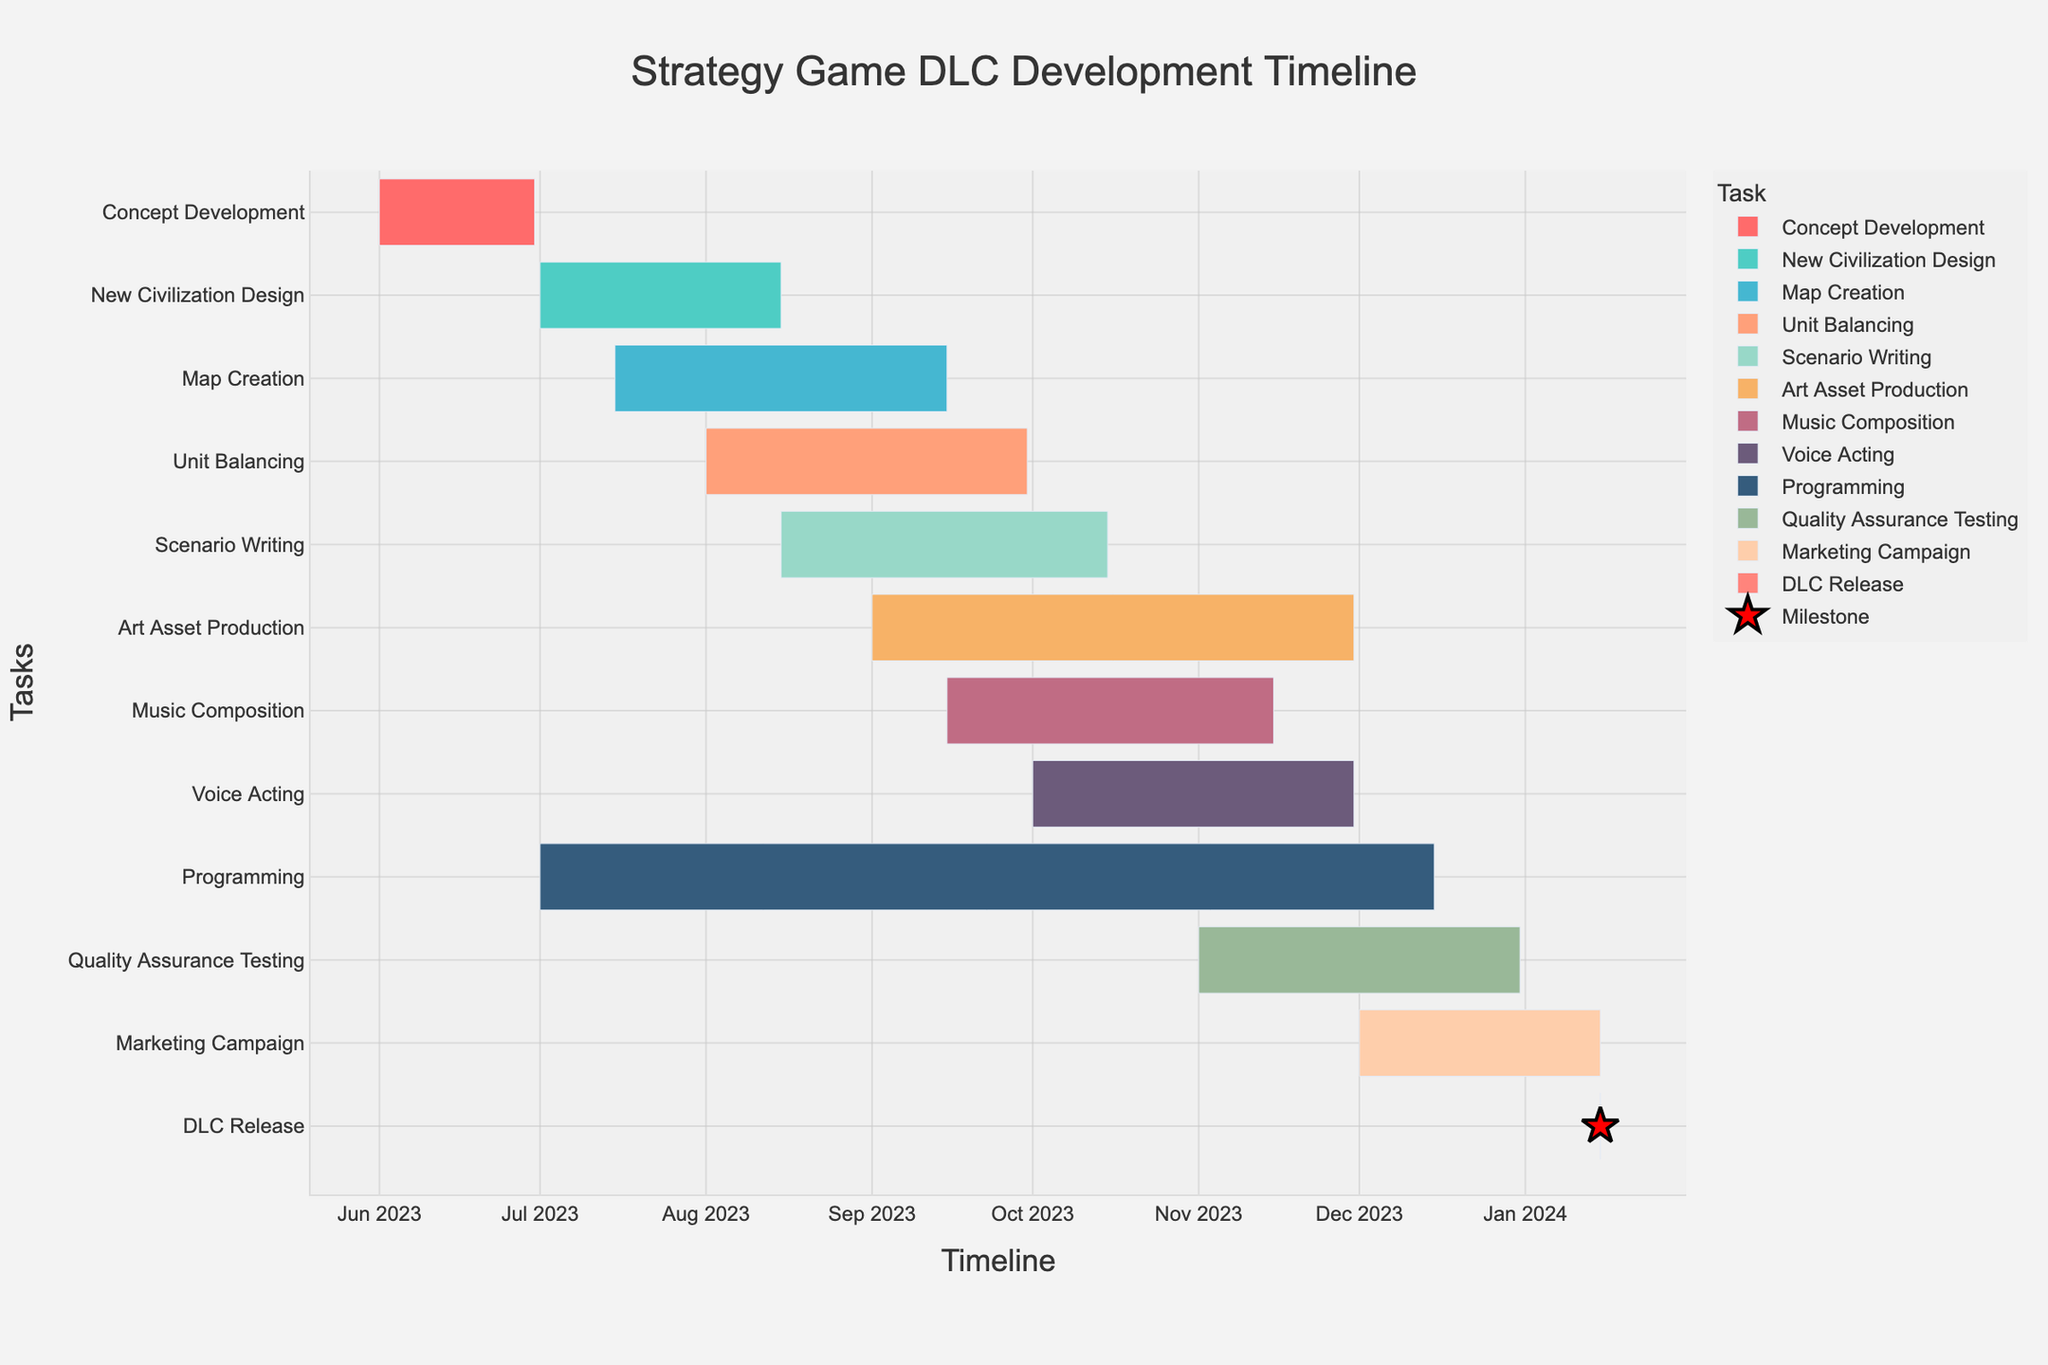What task has the shortest duration? Look at the figure to find the task with the shortest bar. The DLC Release task is the shortest as it starts and ends on the same day.
Answer: DLC Release Which task starts right after Concept Development? Check the end date of Concept Development (June 30, 2023) and look for the task that begins immediately (July 1, 2023).
Answer: New Civilization Design How long is the Programming task? Find the duration of the Programming task by identifying its start (July 1, 2023) and end date (December 15, 2023). Calculate the difference.
Answer: 168 days Which two tasks overlap the most in time? Identify the tasks with the greatest overlap visually by observing overlapping bars. New Civilization Design and Map Creation overlap the most from July 15, 2023, to August 15, 2023.
Answer: New Civilization Design and Map Creation What is the total duration of the entire timeline from the start of Concept Development to the DLC Release? Identify the start of Concept Development (June 1, 2023) and the end of the DLC Release Task (January 15, 2024) and calculate the difference.
Answer: 229 days Which task(s) continues into December 2023? Check the ending dates of tasks to find those that end in December 2023. Programming, Quality Assurance Testing, and Voice Acting continue into December 2023.
Answer: Programming, Quality Assurance Testing, Voice Acting What is the order of tasks that start in August 2023? Identify the tasks that start in August (Unit Balancing, Scenario Writing) and order them by start date.
Answer: Unit Balancing, Scenario Writing How many tasks have end dates in November 2023? Count the tasks that have end dates in November 2023. Three tasks end in November (Art Asset Production, Music Composition, Voice Acting).
Answer: 3 tasks Which tasks are both starting and ending within different colors? Each task has a unique color, but you need to match the task names directly by their start and end periods. All tasks have unique colors, making direct color matching redundant in this context.
Answer: Not applicable 